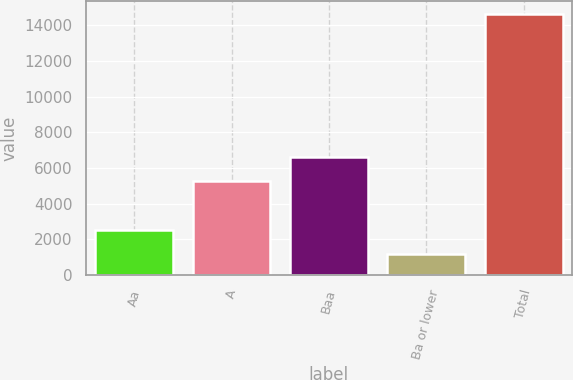Convert chart to OTSL. <chart><loc_0><loc_0><loc_500><loc_500><bar_chart><fcel>Aa<fcel>A<fcel>Baa<fcel>Ba or lower<fcel>Total<nl><fcel>2536.4<fcel>5264<fcel>6606.4<fcel>1194<fcel>14618<nl></chart> 